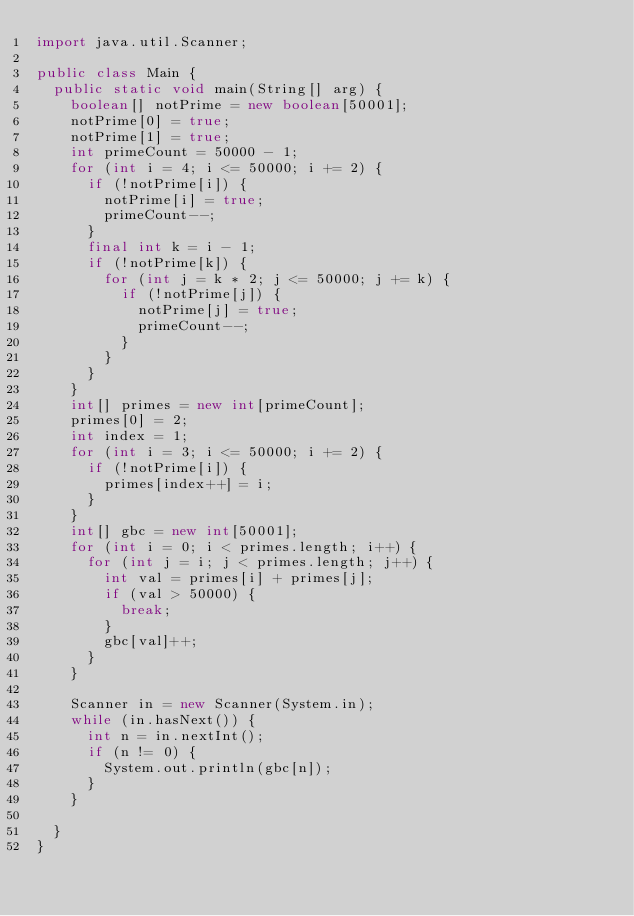<code> <loc_0><loc_0><loc_500><loc_500><_Java_>import java.util.Scanner;

public class Main {
	public static void main(String[] arg) {
		boolean[] notPrime = new boolean[50001];
		notPrime[0] = true;
		notPrime[1] = true;
		int primeCount = 50000 - 1;
		for (int i = 4; i <= 50000; i += 2) {
			if (!notPrime[i]) {
				notPrime[i] = true;
				primeCount--;
			}
			final int k = i - 1;
			if (!notPrime[k]) {
				for (int j = k * 2; j <= 50000; j += k) {
					if (!notPrime[j]) {
						notPrime[j] = true;
						primeCount--;
					}
				}
			}
		}
		int[] primes = new int[primeCount];
		primes[0] = 2;
		int index = 1;
		for (int i = 3; i <= 50000; i += 2) {
			if (!notPrime[i]) {
				primes[index++] = i;
			}
		}
		int[] gbc = new int[50001];
		for (int i = 0; i < primes.length; i++) {
			for (int j = i; j < primes.length; j++) {
				int val = primes[i] + primes[j];
				if (val > 50000) {
					break;
				}
				gbc[val]++;
			}
		}

		Scanner in = new Scanner(System.in);
		while (in.hasNext()) {
			int n = in.nextInt();
			if (n != 0) {
				System.out.println(gbc[n]);
			}
		}

	}
}</code> 